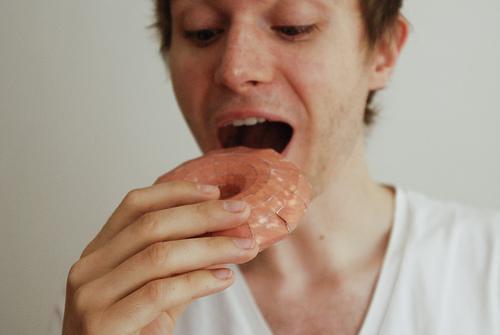How many blue trucks are there?
Give a very brief answer. 0. 